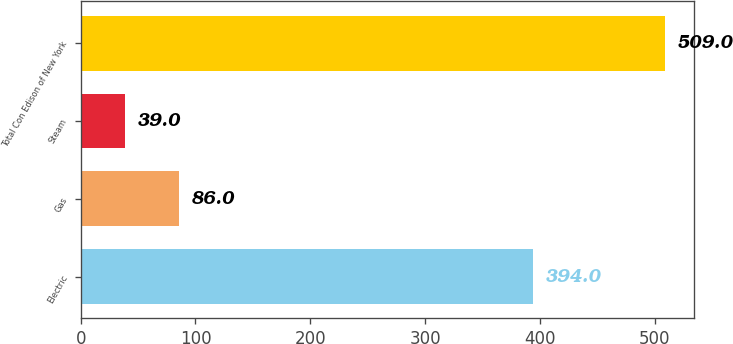Convert chart to OTSL. <chart><loc_0><loc_0><loc_500><loc_500><bar_chart><fcel>Electric<fcel>Gas<fcel>Steam<fcel>Total Con Edison of New York<nl><fcel>394<fcel>86<fcel>39<fcel>509<nl></chart> 